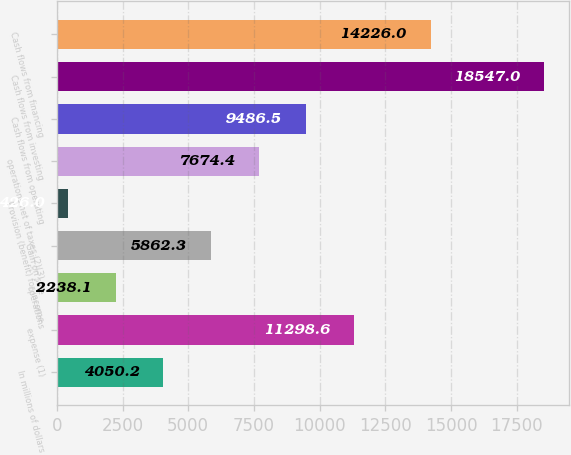Convert chart to OTSL. <chart><loc_0><loc_0><loc_500><loc_500><bar_chart><fcel>In millions of dollars<fcel>expense (1)<fcel>operations<fcel>Gain on sale<fcel>Provision (benefit) for income<fcel>operations net of taxes (2)(3)<fcel>Cash flows from operating<fcel>Cash flows from investing<fcel>Cash flows from financing<nl><fcel>4050.2<fcel>11298.6<fcel>2238.1<fcel>5862.3<fcel>426<fcel>7674.4<fcel>9486.5<fcel>18547<fcel>14226<nl></chart> 